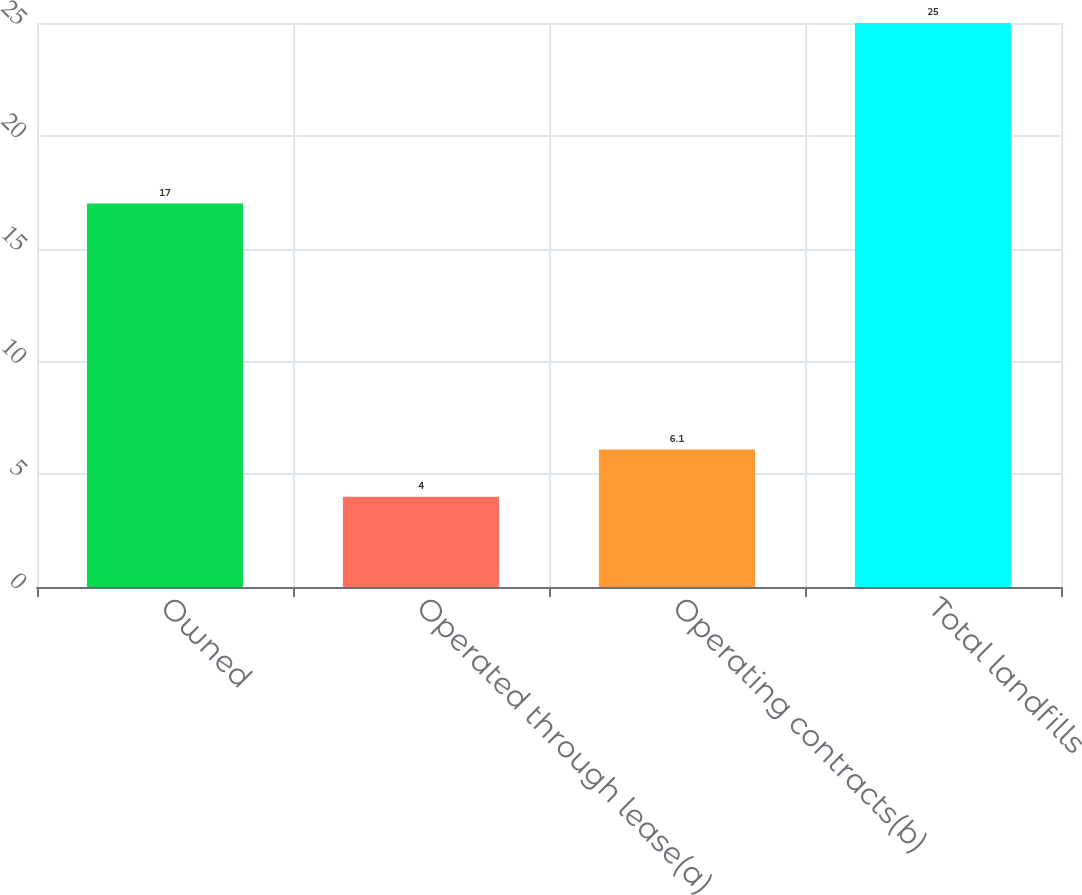Convert chart. <chart><loc_0><loc_0><loc_500><loc_500><bar_chart><fcel>Owned<fcel>Operated through lease(a)<fcel>Operating contracts(b)<fcel>Total landfills<nl><fcel>17<fcel>4<fcel>6.1<fcel>25<nl></chart> 